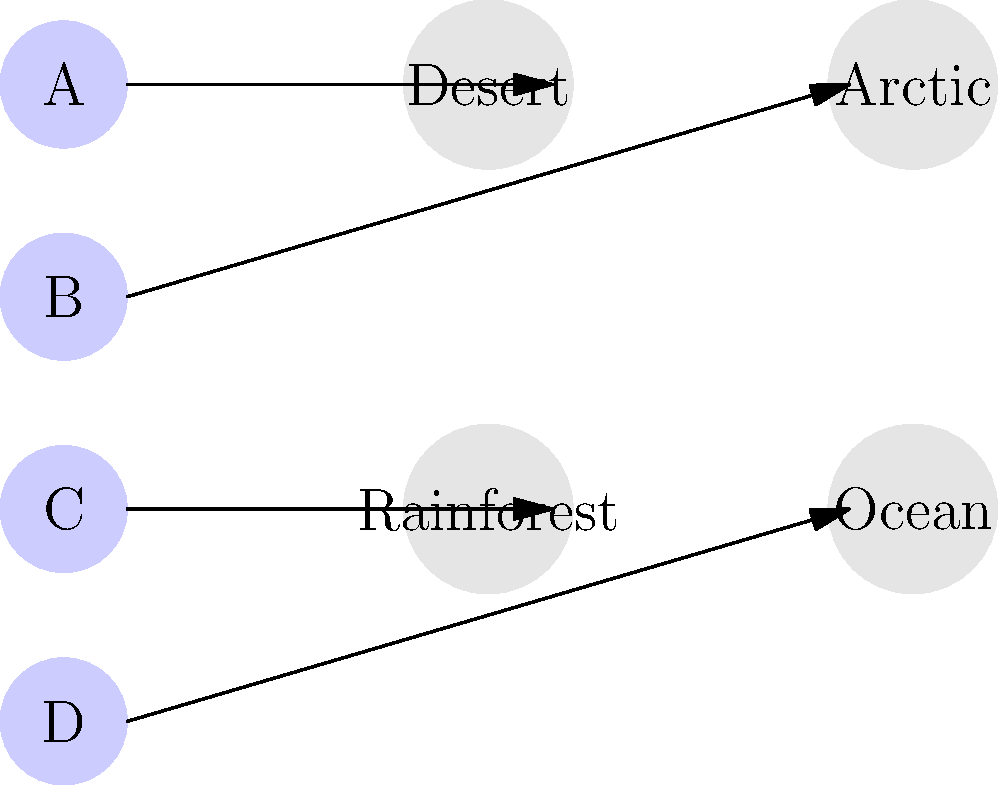As a science journalist preparing an article on animal adaptations, you've been given this diagram showing four animals (A, B, C, D) and four habitats. Based on your understanding of zoology and animal adaptations, match each animal to its most suitable habitat:

A. An animal with large, flat feet and thick white fur
B. An animal with a streamlined body and fins
C. An animal with a long, sticky tongue and bright colors
D. An animal with large ears and the ability to store water in its hump

Which animal-habitat pairing is correct? To answer this question, we need to analyze the characteristics of each animal and match them to the most suitable habitat:

1. Animal A: Large, flat feet and thick white fur
   - These adaptations are typical for animals living in cold, snowy environments.
   - The thick white fur provides camouflage and insulation.
   - Large, flat feet help distribute weight when walking on snow.
   - This animal is best suited for the Arctic habitat.

2. Animal B: Streamlined body and fins
   - These features are adaptations for efficient movement in water.
   - A streamlined body reduces drag while swimming.
   - Fins provide propulsion and steering in an aquatic environment.
   - This animal is best suited for the Ocean habitat.

3. Animal C: Long, sticky tongue and bright colors
   - A long, sticky tongue is often used to catch insects.
   - Bright colors in animals are often associated with warning predators or attracting mates.
   - These adaptations are common in tropical environments with abundant insect life.
   - This animal is best suited for the Rainforest habitat.

4. Animal D: Large ears and ability to store water in its hump
   - Large ears help dissipate heat in hot environments.
   - The ability to store water is crucial for survival in arid conditions.
   - These adaptations are typical for animals living in hot, dry climates.
   - This animal is best suited for the Desert habitat.

By process of elimination and matching the adaptations to the most suitable environments, we can conclude that the correct pairing is Animal A with the Arctic habitat.
Answer: Animal A - Arctic 